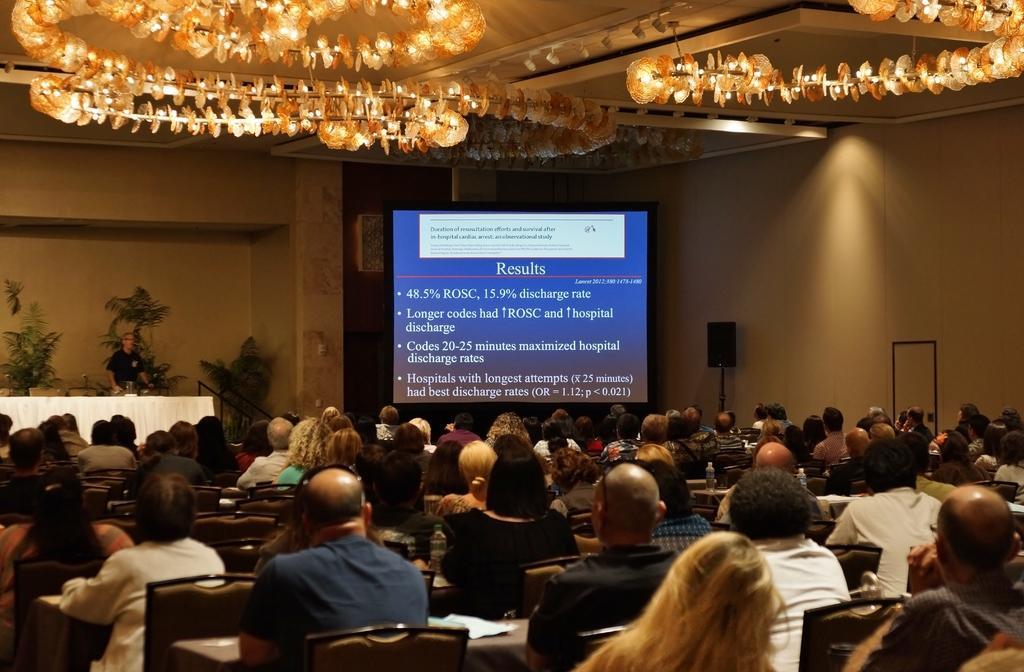In one or two sentences, can you explain what this image depicts? In this image we can see some persons, bottles, chairs and other objects. In the background of the image there is a person, screen, chair, plants, wall and other objects. At the top of the image there is the ceiling, lights and some decorative objects. 